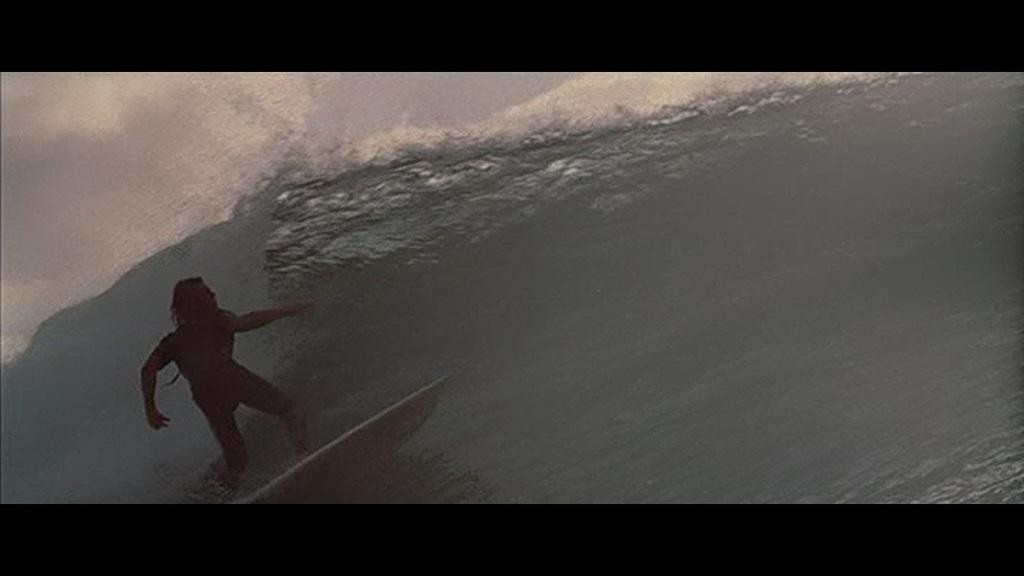What is the main subject of the image? There is a person in the image. What is the person doing in the image? The person is standing on a surfboard and surfing on water with tides. Where is the person located in the image? The person is on the left side of the image. What can be seen in the background of the image? The sky is visible at the left top of the image. What type of park is visible in the image? There is no park present in the image; it features a person surfing on water with tides. What is the company's name that the person is representing in the image? There is no company mentioned or represented in the image. 